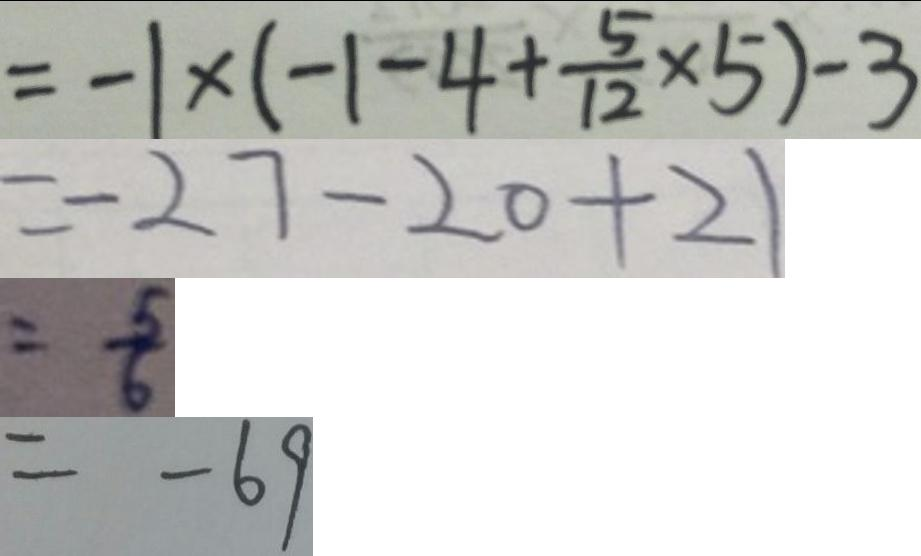Convert formula to latex. <formula><loc_0><loc_0><loc_500><loc_500>= - 1 \times ( - 1 - 4 + \frac { 5 } { 1 2 } \times 5 ) - 3 
 = - 2 7 - 2 0 + 2 1 
 = \frac { 5 } { 6 } 
 = - 6 9</formula> 